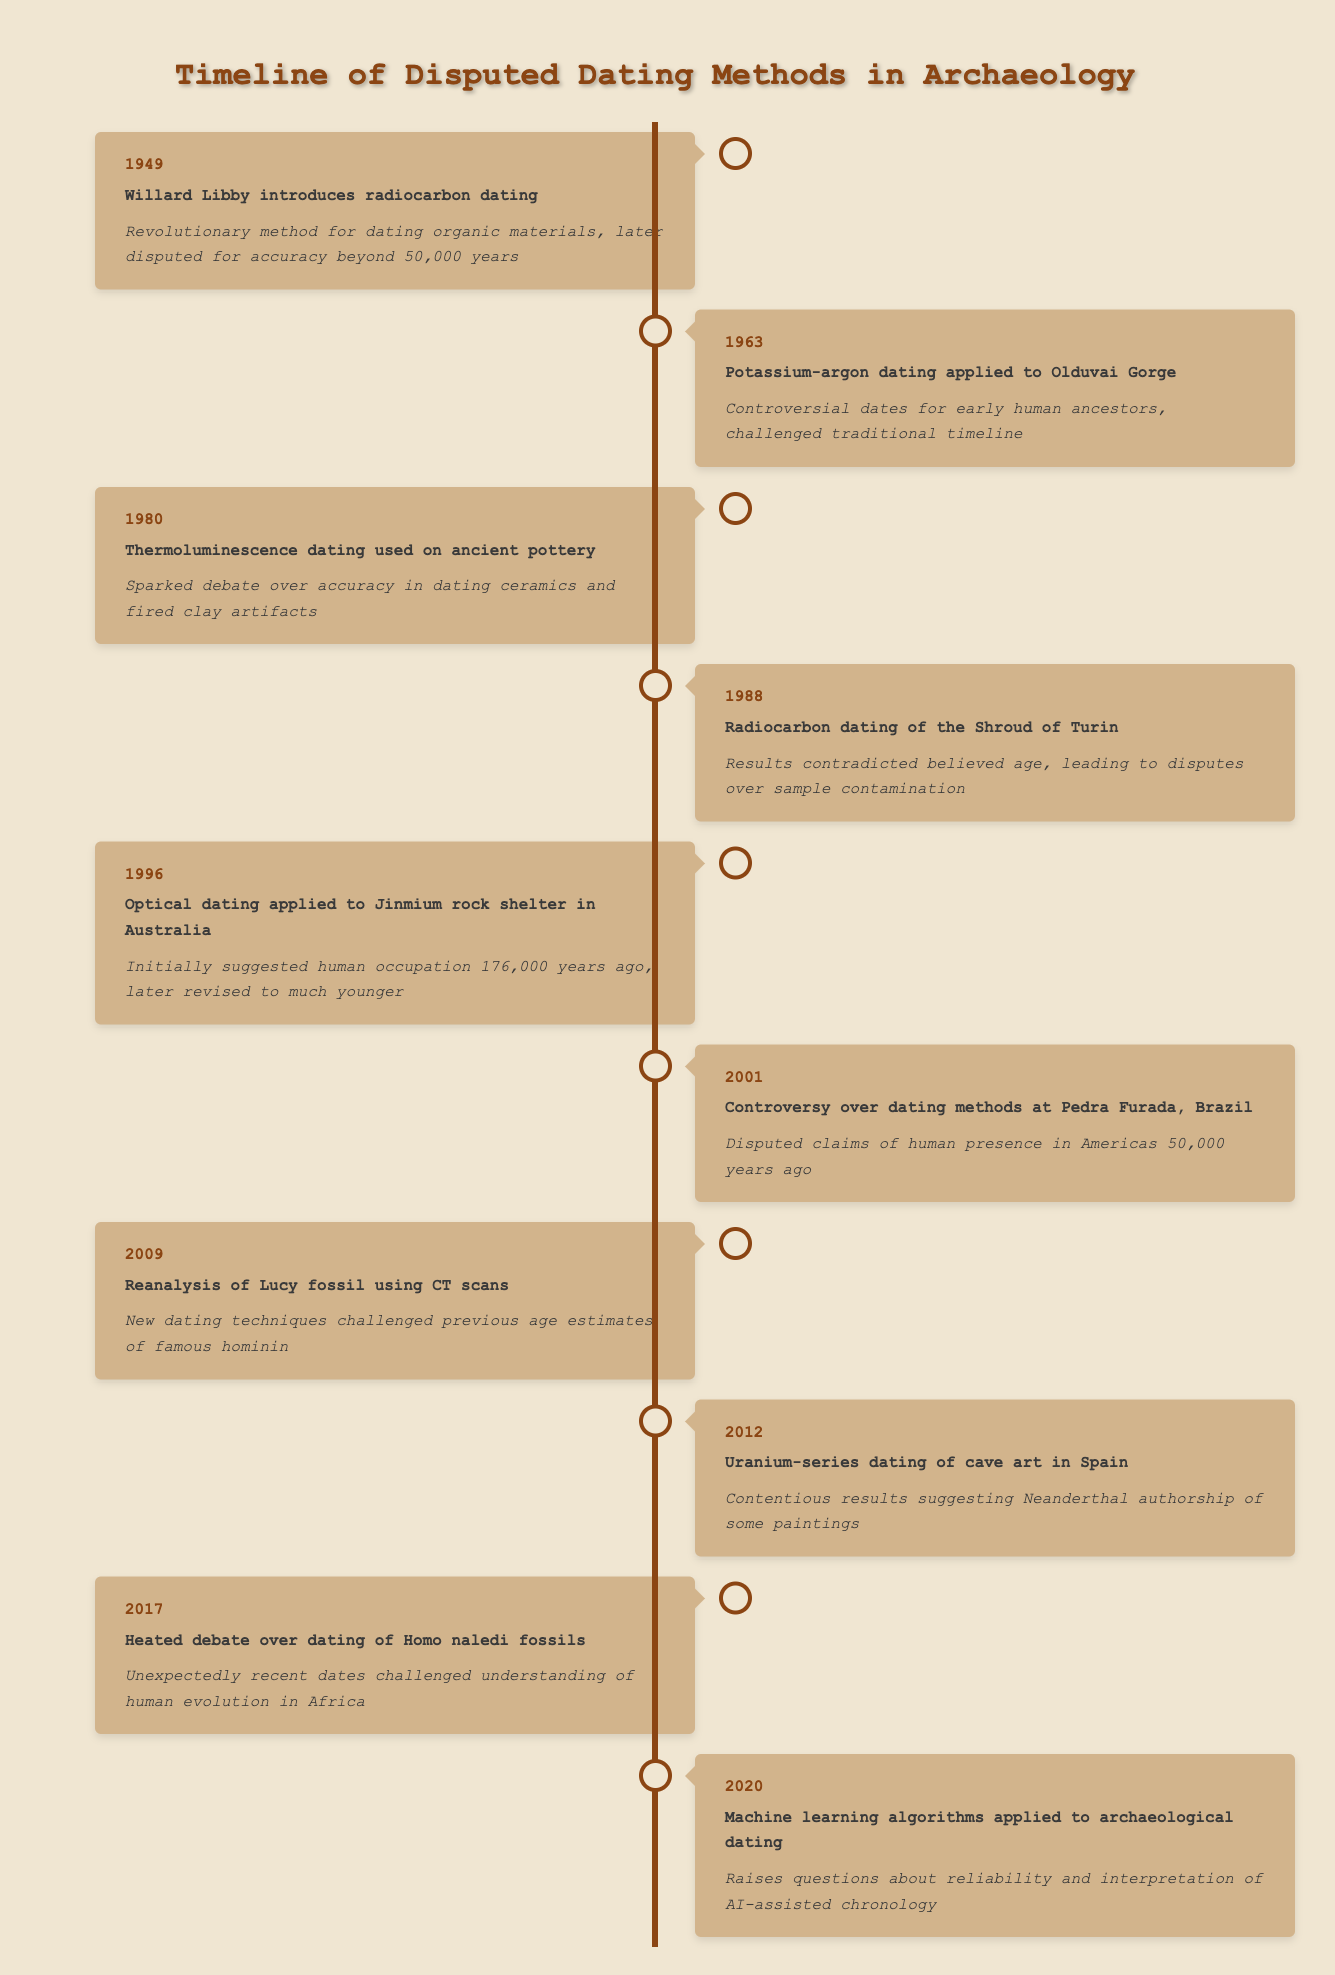What year was radiocarbon dating introduced? The table lists the event of "Willard Libby introduces radiocarbon dating" in the year 1949.
Answer: 1949 What significant dating method was applied to the Olduvai Gorge in 1963? The table details that in 1963, potassium-argon dating was applied to Olduvai Gorge.
Answer: Potassium-argon dating Which method sparked debate over dating ceramics in 1980? According to the table, thermoluminescence dating was used on ancient pottery in 1980, which sparked the debate.
Answer: Thermoluminescence dating How many years apart were the controversies concerning the Shroud of Turin and Pedra Furada? The Shroud of Turin dating controversy occurred in 1988, while the Pedra Furada controversy happened in 2001. To calculate the difference: 2001 - 1988 = 13 years.
Answer: 13 years Did uranium-series dating suggest Neanderthal authorship of cave art in Spain? The table states that uranium-series dating showed contentious results suggesting Neanderthal authorship, indicating that the statement is true.
Answer: Yes What event in 2017 challenged the understanding of human evolution in Africa? The table notes "Heated debate over dating of Homo naledi fossils" in 2017, which challenged the understanding of human evolution in Africa.
Answer: Heated debate over dating of Homo naledi fossils Which dating method was introduced most recently according to the table? The latest entry in the timeline shows that machine learning algorithms were applied to archaeological dating in 2020, making it the most recent method.
Answer: Machine learning algorithms Which two events occurred in the 1980s? The table shows two events in the 1980s: "Thermoluminescence dating used on ancient pottery" in 1980 and "Radiocarbon dating of the Shroud of Turin" in 1988. Both are noted in the timeline within that decade.
Answer: Thermoluminescence dating and Radiocarbon dating of the Shroud of Turin What is the main significance of the 2009 event involving the Lucy fossil? The entry for 2009 states that the reanalysis of the Lucy fossil using CT scans challenged previous age estimates, indicating a significant development in dating techniques.
Answer: Challenged previous age estimates When were the earliest dating methods introduced in this timeline? The first event in the timeline is from 1949, which introduces radiocarbon dating, indicating that it is the earliest method listed.
Answer: 1949 